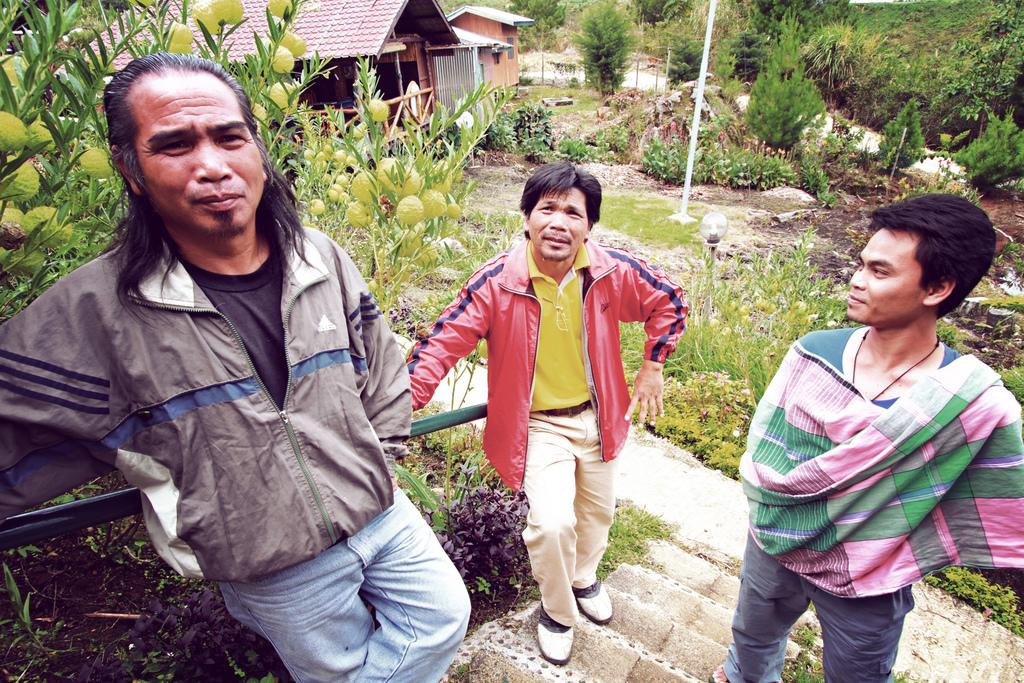What type of structures can be seen in the image? There are houses in the image. What can be observed in the natural environment in the image? There are many trees and plants in the image. Are there any architectural features visible in the image? Yes, there are staircases in the image. How many people are present in the image? There are three people in the image. What type of nut can be seen being cracked by a laborer in the image? There is no laborer or nut present in the image. What type of wave can be seen crashing on the shore in the image? There is no shore or wave present in the image. 